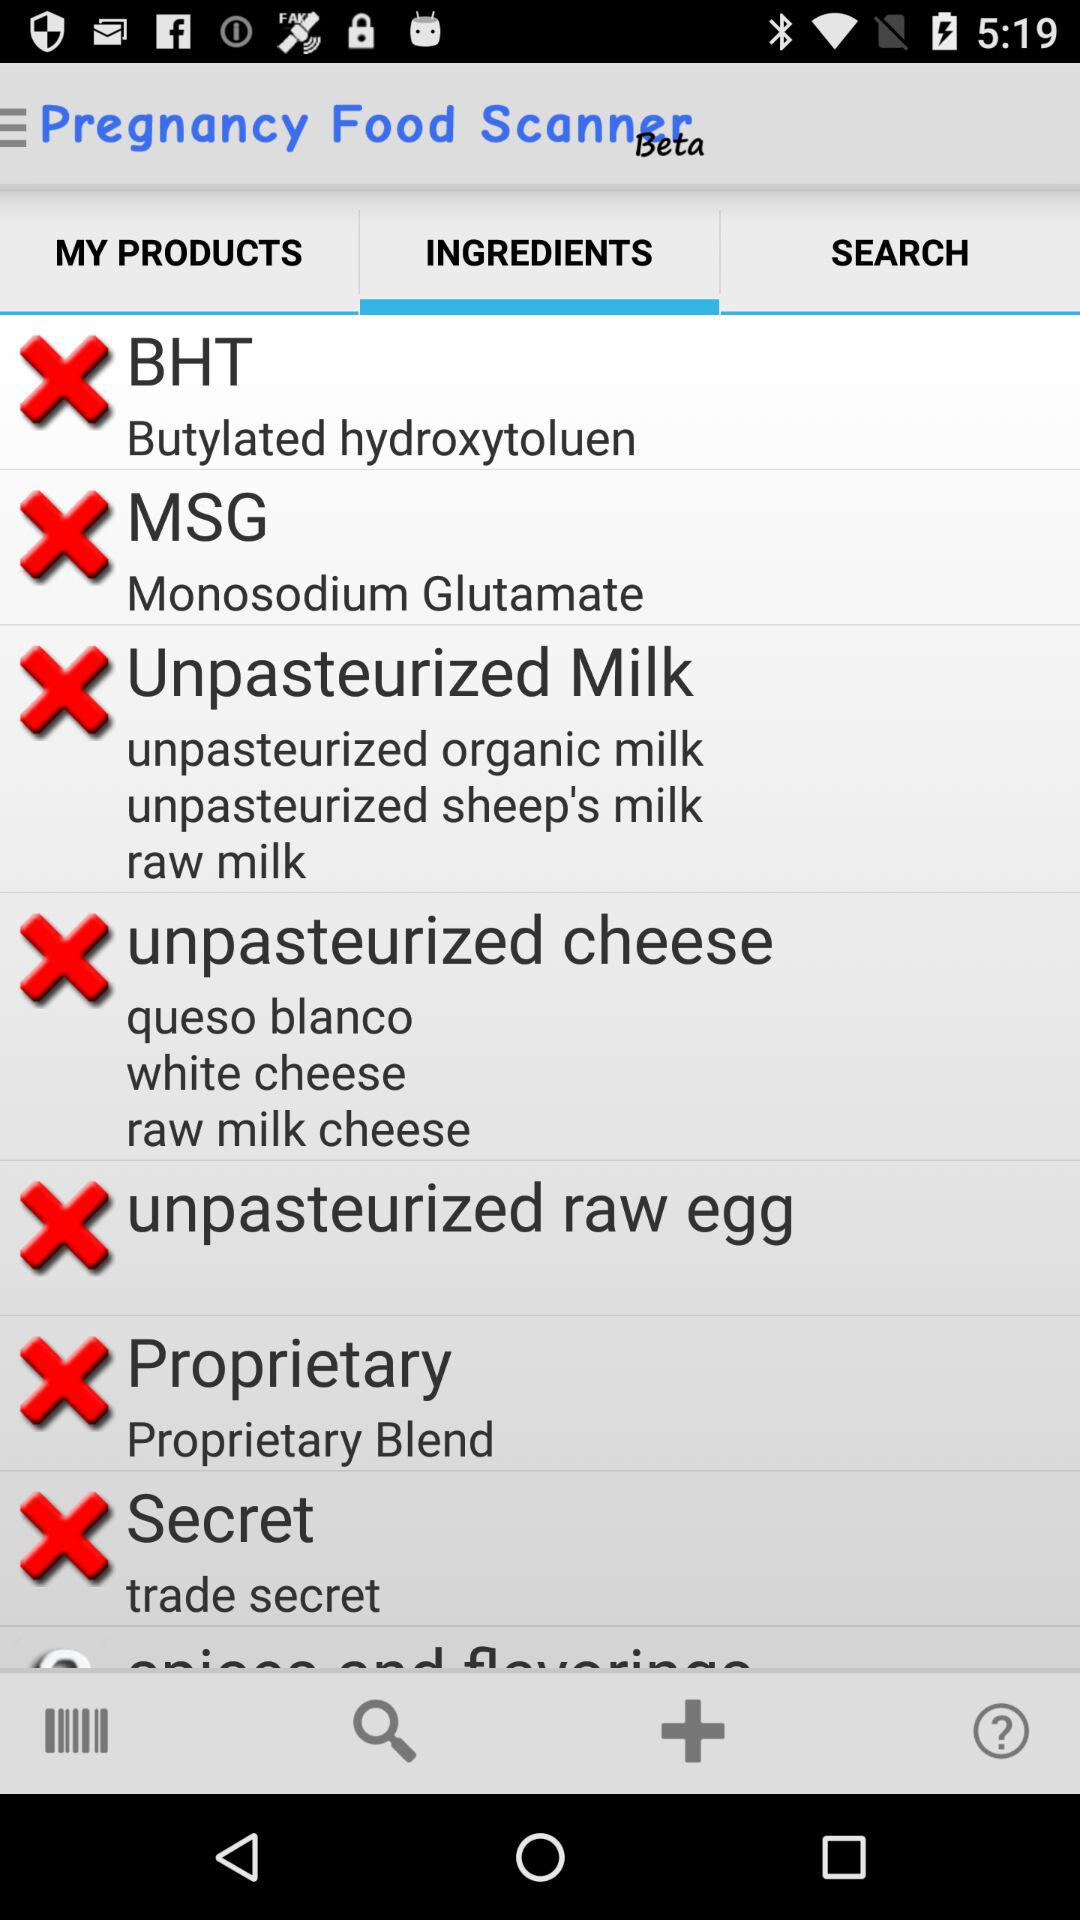What is the name of the application? The name of the application is "Pregnancy Food Scanner". 